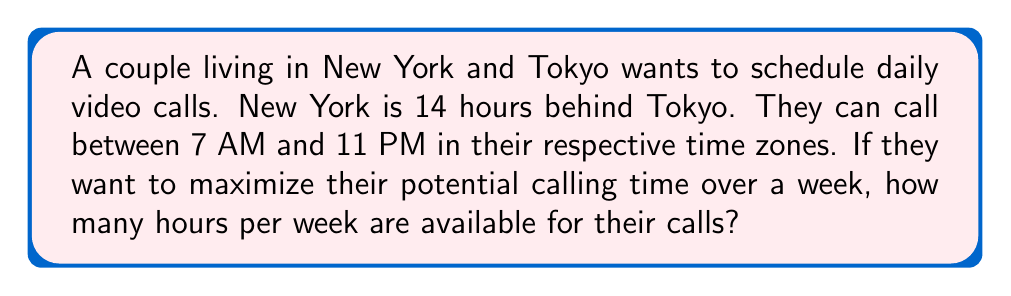Show me your answer to this math problem. Let's approach this step-by-step:

1) First, let's convert the available times to a 24-hour format:
   New York: 7:00 - 23:00
   Tokyo: 7:00 - 23:00

2) Now, let's adjust Tokyo's time to New York's time zone:
   Tokyo in NY time: 17:00 (previous day) - 9:00 (current day)

3) The overlapping time is from 7:00 to 9:00 New York time, which is 21:00 to 23:00 Tokyo time.

4) This gives us a 2-hour window each day.

5) To calculate the total time per week:
   $$\text{Total time} = 2 \text{ hours} \times 7 \text{ days} = 14 \text{ hours}$$

Therefore, the couple has 14 hours per week available for their calls.
Answer: 14 hours 